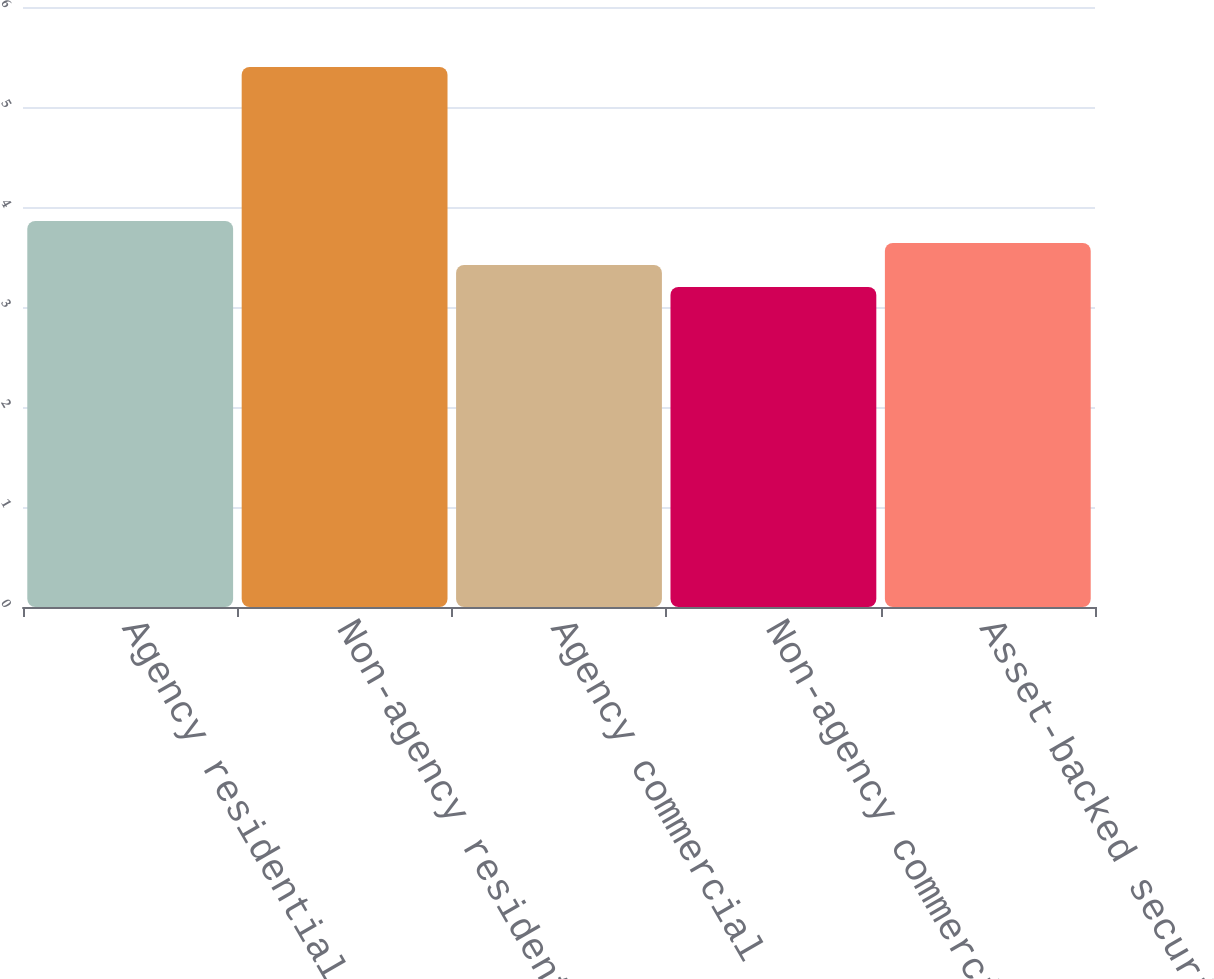Convert chart to OTSL. <chart><loc_0><loc_0><loc_500><loc_500><bar_chart><fcel>Agency residential<fcel>Non-agency residential<fcel>Agency commercial<fcel>Non-agency commercial<fcel>Asset-backed securities<nl><fcel>3.86<fcel>5.4<fcel>3.42<fcel>3.2<fcel>3.64<nl></chart> 